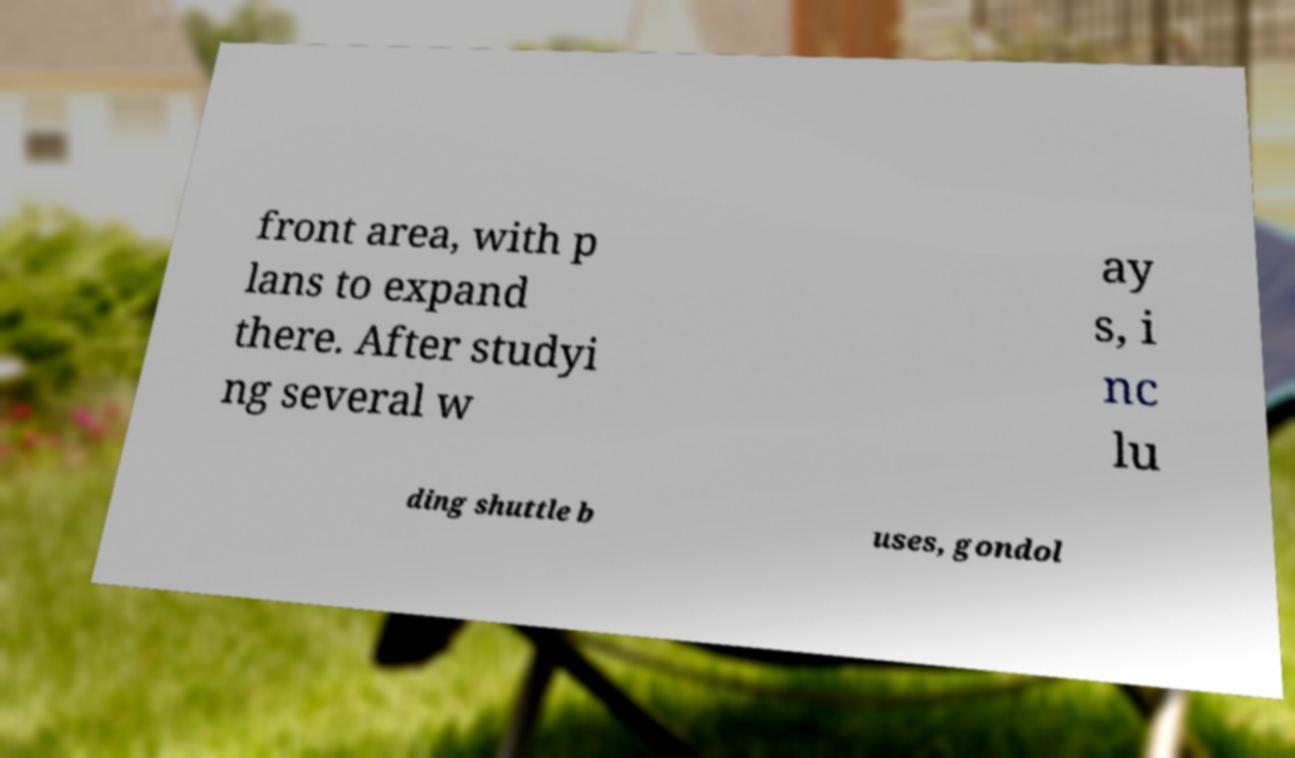I need the written content from this picture converted into text. Can you do that? front area, with p lans to expand there. After studyi ng several w ay s, i nc lu ding shuttle b uses, gondol 